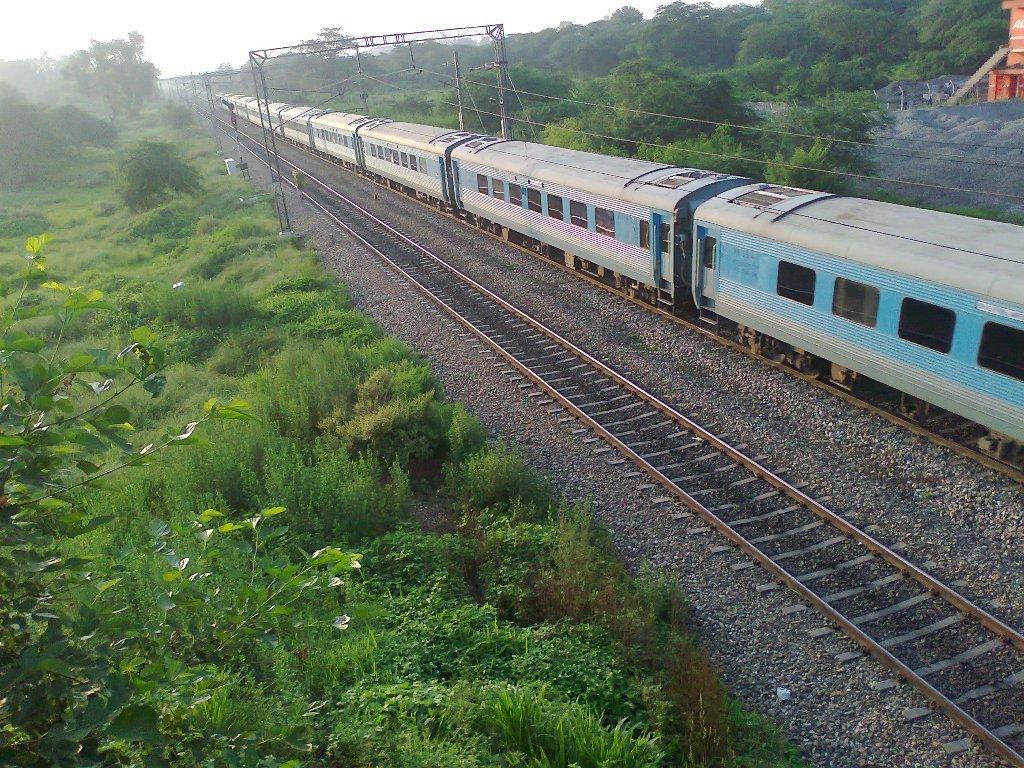What is the main subject of the image? The main subject of the image is a train. What can be seen beneath the train? Railway tracks are visible in the image. What else is present in the image besides the train and railway tracks? Wires, trees, and a building are present in the image. What is visible at the top of the image? The sky is visible at the top of the image. How many babies are playing with the mind in the image? There are no babies or minds present in the image. What type of crush is the train experiencing in the image? Trains do not experience crushes; they are inanimate objects. 